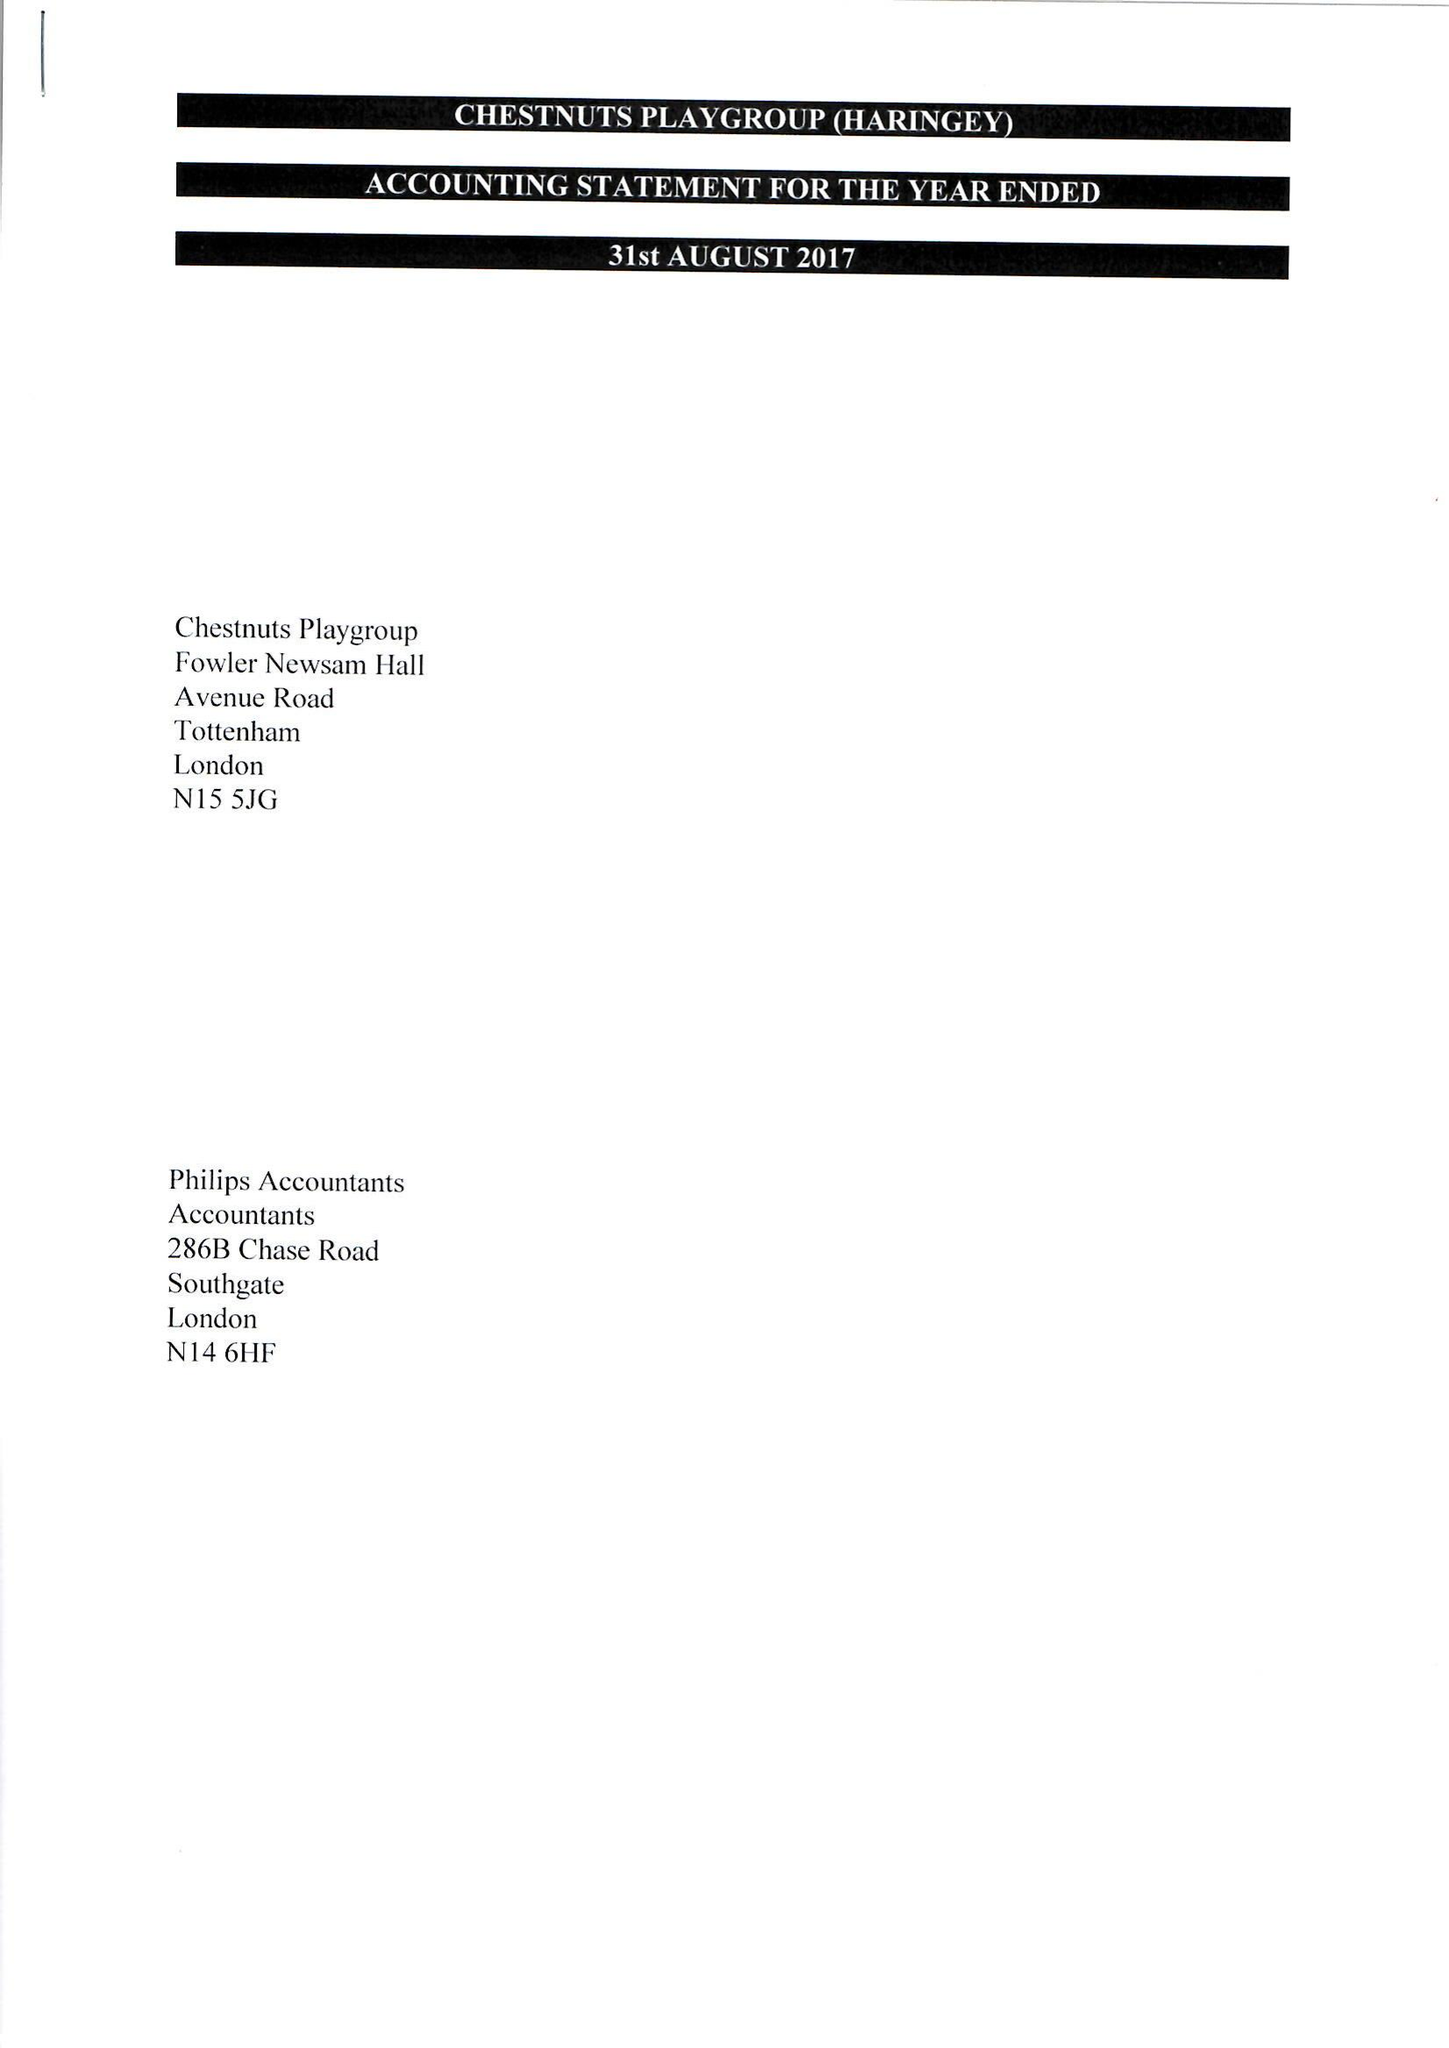What is the value for the charity_number?
Answer the question using a single word or phrase. 1037148 